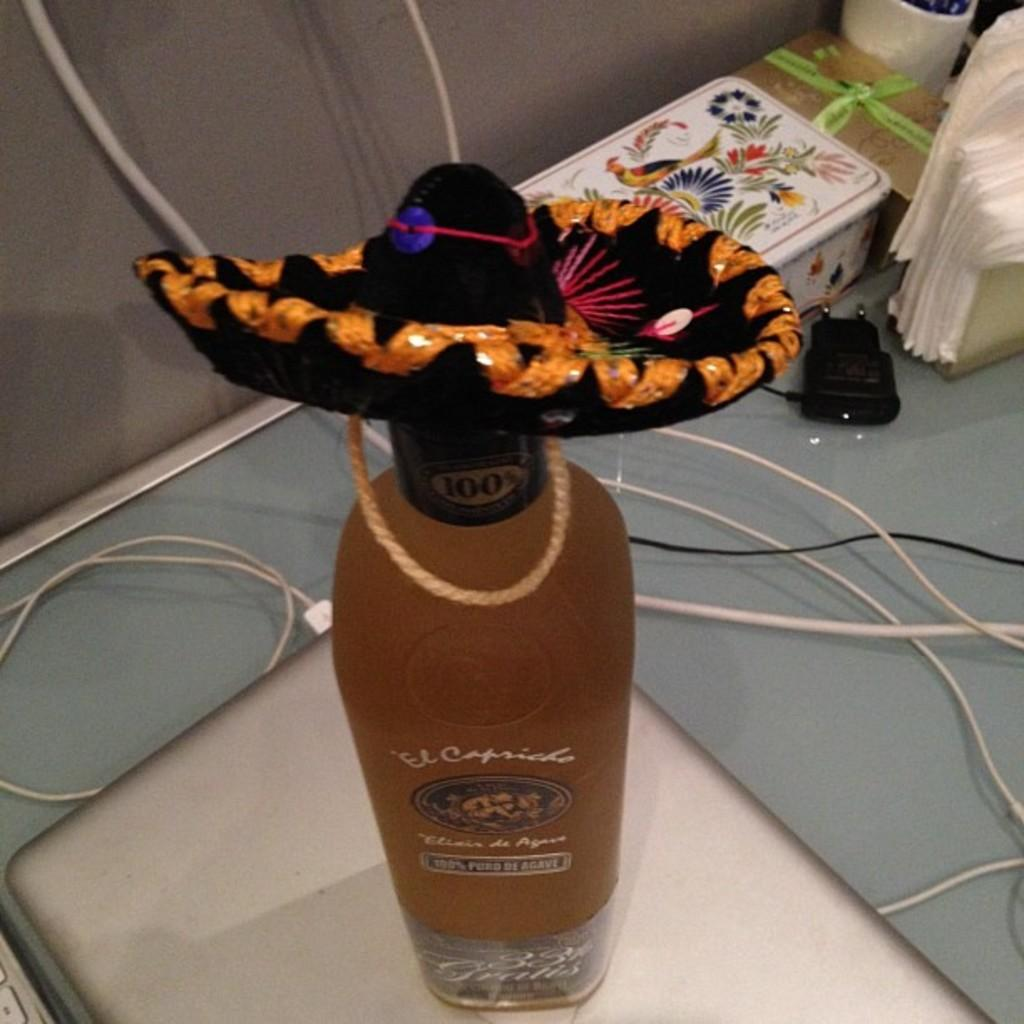What objects are on the table in the image? There is a bottle, a laptop, a wire, a charger, a box, a cup, and tissues on the table in the image. Can you describe the wire on the table? The wire on the table is likely a charging cable or a cable connecting the laptop to another device. What might the charger be used for? The charger on the table is likely used to charge the laptop or another electronic device. How many items are on the table in the image? There are seven items on the table in the image: a bottle, a laptop, a wire, a charger, a box, a cup, and tissues. What type of mitten is being used to operate the laptop in the image? There is no mitten present in the image, and the laptop is being operated with hands, not mittens. 